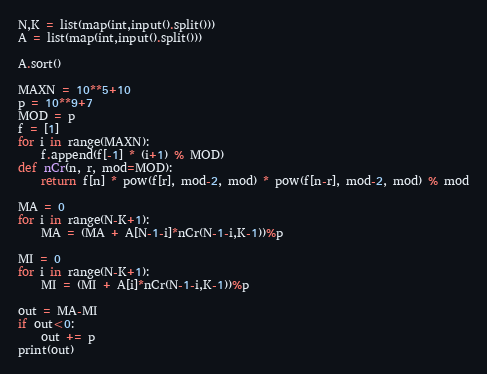<code> <loc_0><loc_0><loc_500><loc_500><_Python_>N,K = list(map(int,input().split()))
A = list(map(int,input().split()))

A.sort()

MAXN = 10**5+10
p = 10**9+7
MOD = p
f = [1]
for i in range(MAXN):
    f.append(f[-1] * (i+1) % MOD)
def nCr(n, r, mod=MOD):
    return f[n] * pow(f[r], mod-2, mod) * pow(f[n-r], mod-2, mod) % mod

MA = 0
for i in range(N-K+1):
    MA = (MA + A[N-1-i]*nCr(N-1-i,K-1))%p

MI = 0
for i in range(N-K+1):
    MI = (MI + A[i]*nCr(N-1-i,K-1))%p

out = MA-MI
if out<0:
    out += p
print(out)</code> 